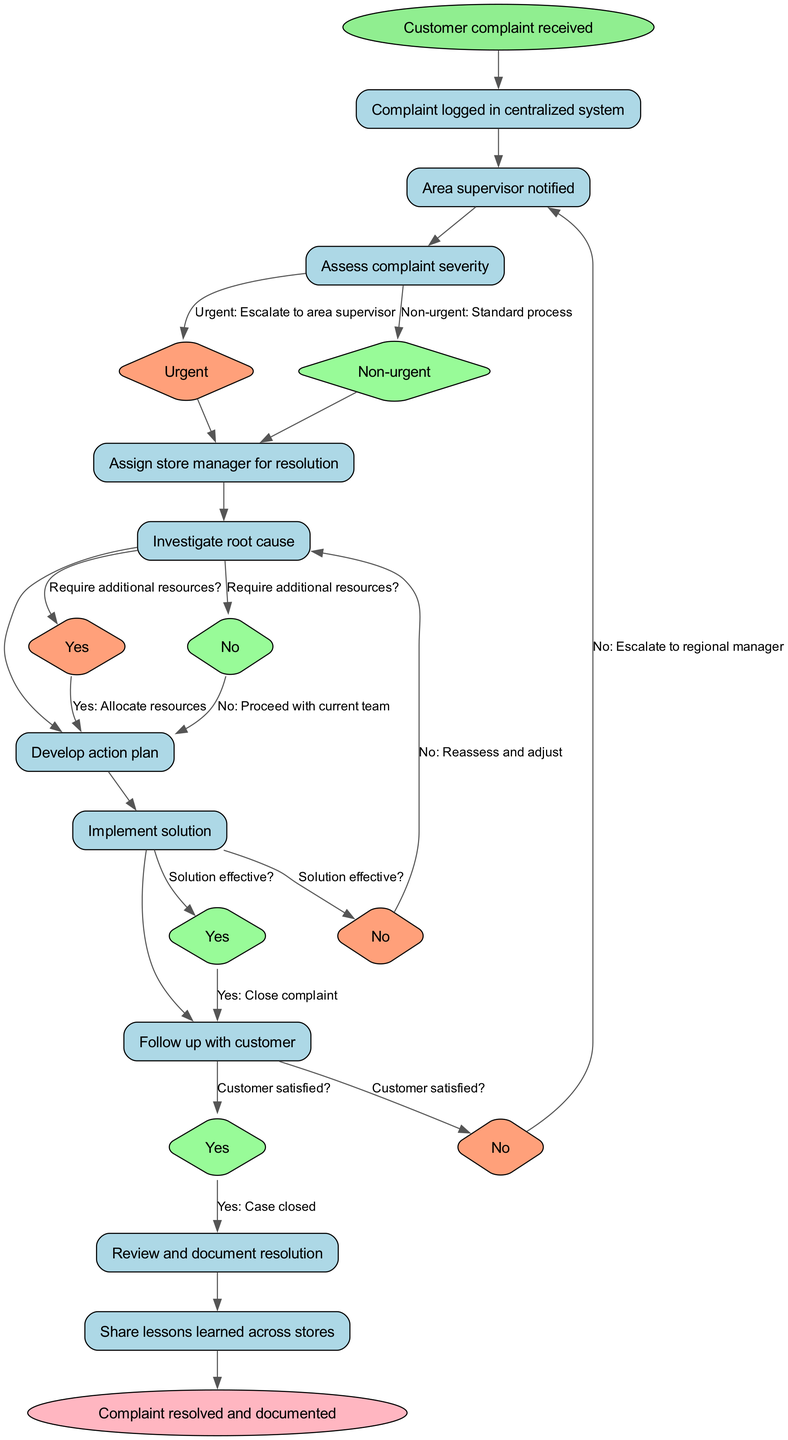What is the first node in the clinical pathway? The first node in the diagram, where the process starts, is labeled "Customer complaint received." This is the initial step before any actions are taken.
Answer: Customer complaint received How many nodes are present in the diagram? The diagram contains 10 nodes that represent various steps in the clinical pathway. Each node corresponds to an action or decision point in managing customer complaints.
Answer: 10 What happens after the complaint is logged in the centralized system? After the complaint is logged, the area supervisor is notified. This is the next step, signifying that the situation is being taken seriously.
Answer: Area supervisor notified What is the relationship between "Investigate root cause" and "Develop action plan"? The relationship is sequential; after the investigation of the root cause has been completed, the next step is to develop an action plan, indicating that the investigation informs the planning process.
Answer: Sequential If a complaint is urgent, what is the next step? If a complaint is urgent, the next step is to assign a store manager for resolution, indicating that urgent complaints are escalated for quicker handling.
Answer: Assign store manager for resolution What happens if the solution is not effective? If the solution is not effective, the pathway instructs to reassess and adjust the approach before reiterating the resolution process, indicating an iterative quality to the resolution effort.
Answer: Reassess and adjust How is the customer satisfaction checked in the pathway? Customer satisfaction is assessed after implementing the solution; if the customer is satisfied, the case is closed; if not, it escalates to the regional manager for further attention.
Answer: Assess customer satisfaction What do you do if additional resources are required? If additional resources are required, they are allocated to support the resolution process, indicating that the pathway provides flexibility in handling more complex complaints.
Answer: Allocate resources What represents the end of the clinical pathway? The end of the clinical pathway is represented by the node labeled "Complaint resolved and documented," indicating that the process is complete when the complaint has been concluded and recorded.
Answer: Complaint resolved and documented 